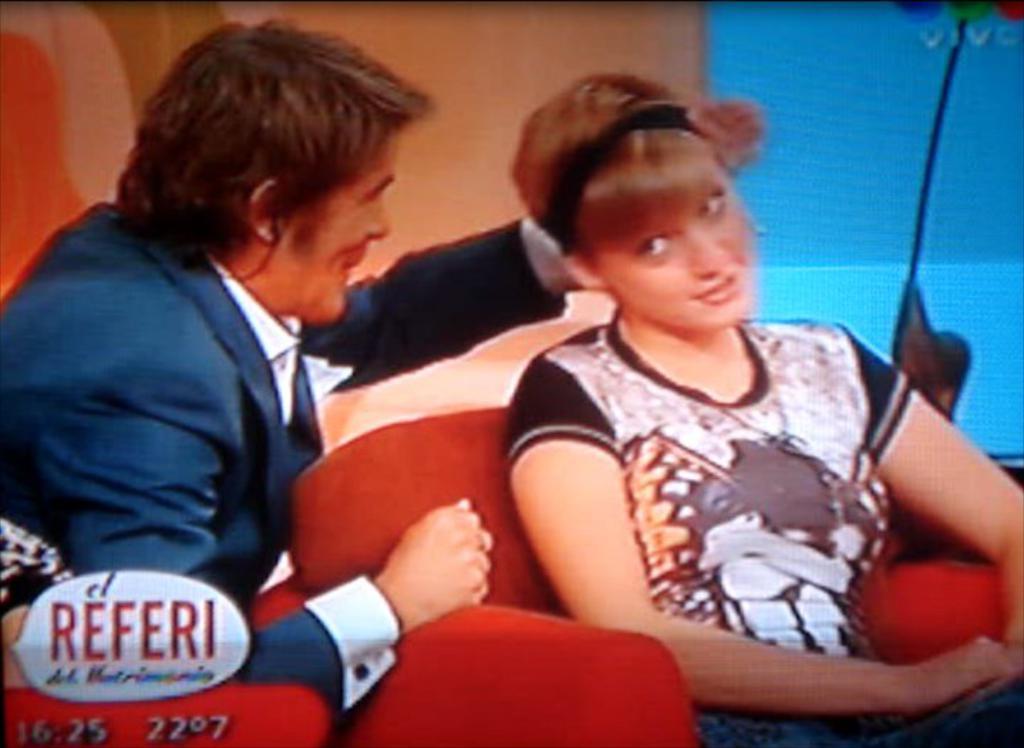How would you summarize this image in a sentence or two? There is one man and a woman is sitting on a sofa chair as we can see in the middle of this image. We can see a watermark in the bottom left corner of this image. 